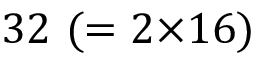<formula> <loc_0><loc_0><loc_500><loc_500>3 2 ( = 2 { \times } 1 6 )</formula> 